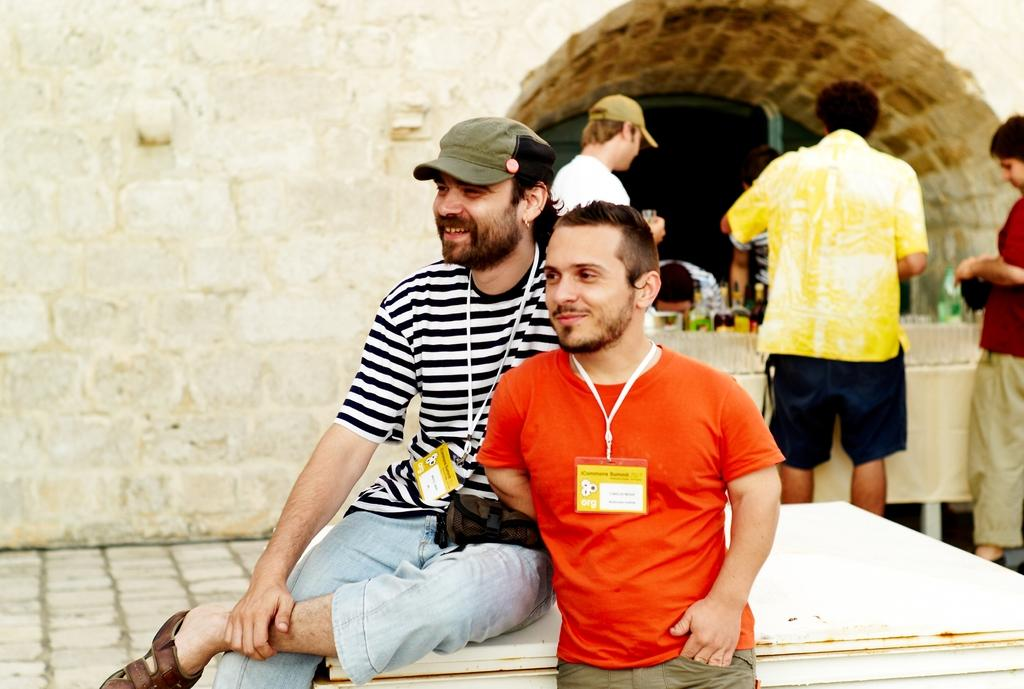How many people are in the image? There are people in the image, but the exact number is not specified. What is the facial expression of some of the people in the image? Two people are smiling in the image. What type of object can be seen in the image that is made of wire? There are wire tags in the image. What can be seen in the background of the image? There is a wall and bottles in the background of the image. What type of planes are flying in the image? There are no planes visible in the image. How many baseballs can be seen in the image? There is no mention of baseballs or any sports equipment in the image. 